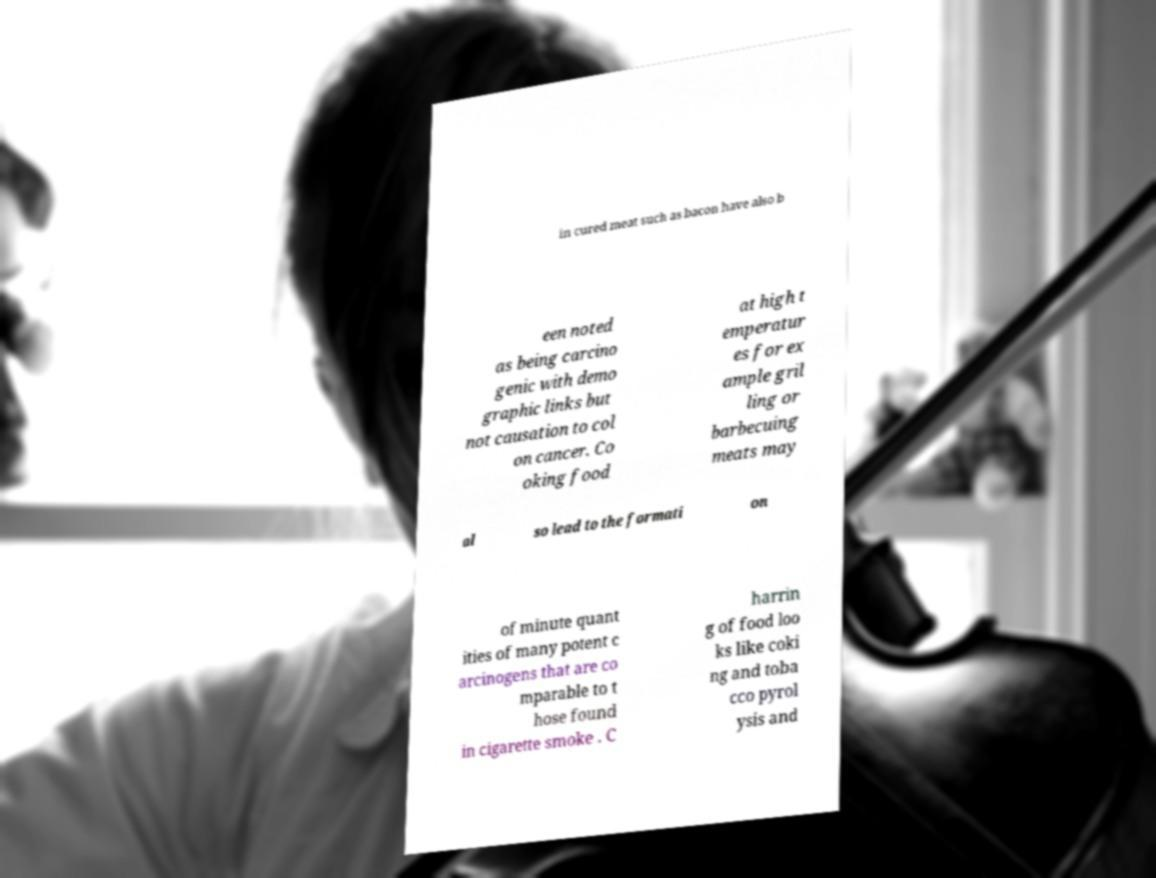For documentation purposes, I need the text within this image transcribed. Could you provide that? in cured meat such as bacon have also b een noted as being carcino genic with demo graphic links but not causation to col on cancer. Co oking food at high t emperatur es for ex ample gril ling or barbecuing meats may al so lead to the formati on of minute quant ities of many potent c arcinogens that are co mparable to t hose found in cigarette smoke . C harrin g of food loo ks like coki ng and toba cco pyrol ysis and 